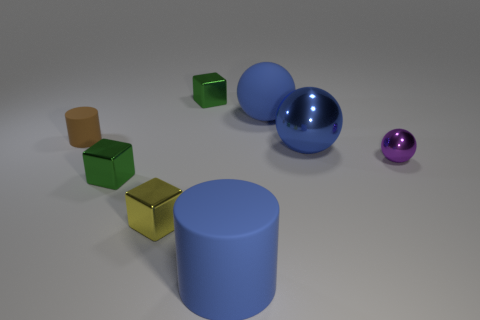Subtract all small green metallic blocks. How many blocks are left? 1 Add 1 large red rubber blocks. How many objects exist? 9 Subtract all green cubes. How many cubes are left? 1 Subtract 2 blocks. How many blocks are left? 1 Add 5 cubes. How many cubes are left? 8 Add 6 yellow shiny cubes. How many yellow shiny cubes exist? 7 Subtract 1 brown cylinders. How many objects are left? 7 Subtract all cubes. How many objects are left? 5 Subtract all brown cubes. Subtract all blue balls. How many cubes are left? 3 Subtract all blue spheres. How many green blocks are left? 2 